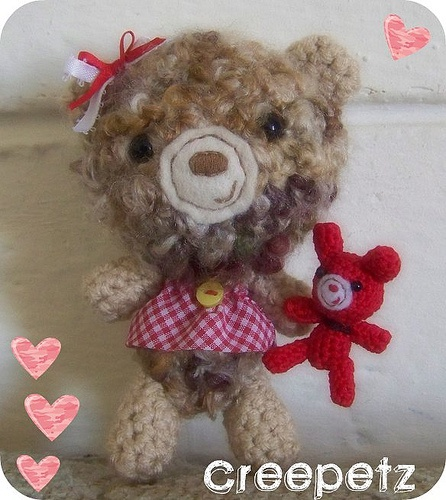Describe the objects in this image and their specific colors. I can see teddy bear in white, gray, darkgray, and maroon tones and teddy bear in white, brown, maroon, and darkgray tones in this image. 